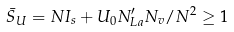Convert formula to latex. <formula><loc_0><loc_0><loc_500><loc_500>\bar { S } _ { U } = N I _ { s } + U _ { 0 } N ^ { \prime } _ { L a } N _ { v } / N ^ { 2 } \geq 1</formula> 